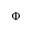<formula> <loc_0><loc_0><loc_500><loc_500>\Phi</formula> 